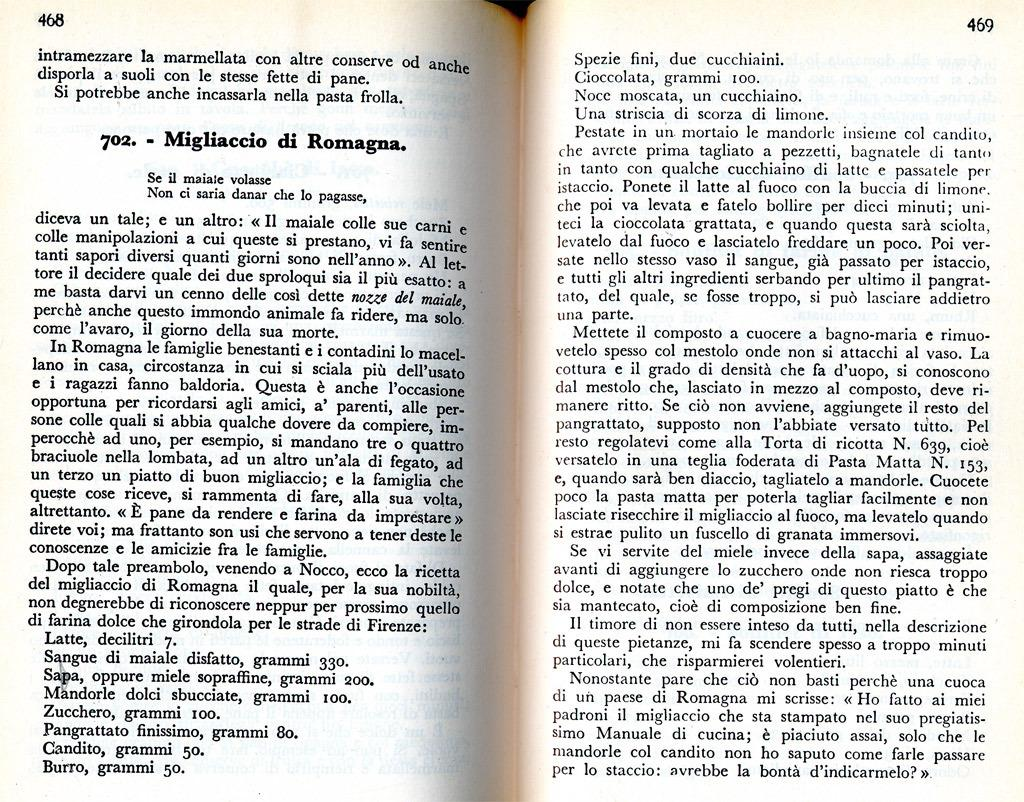<image>
Describe the image concisely. Book open to a story called Migliaccio di Romagna 